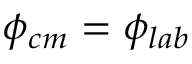<formula> <loc_0><loc_0><loc_500><loc_500>\phi _ { c m } = \phi _ { l a b }</formula> 